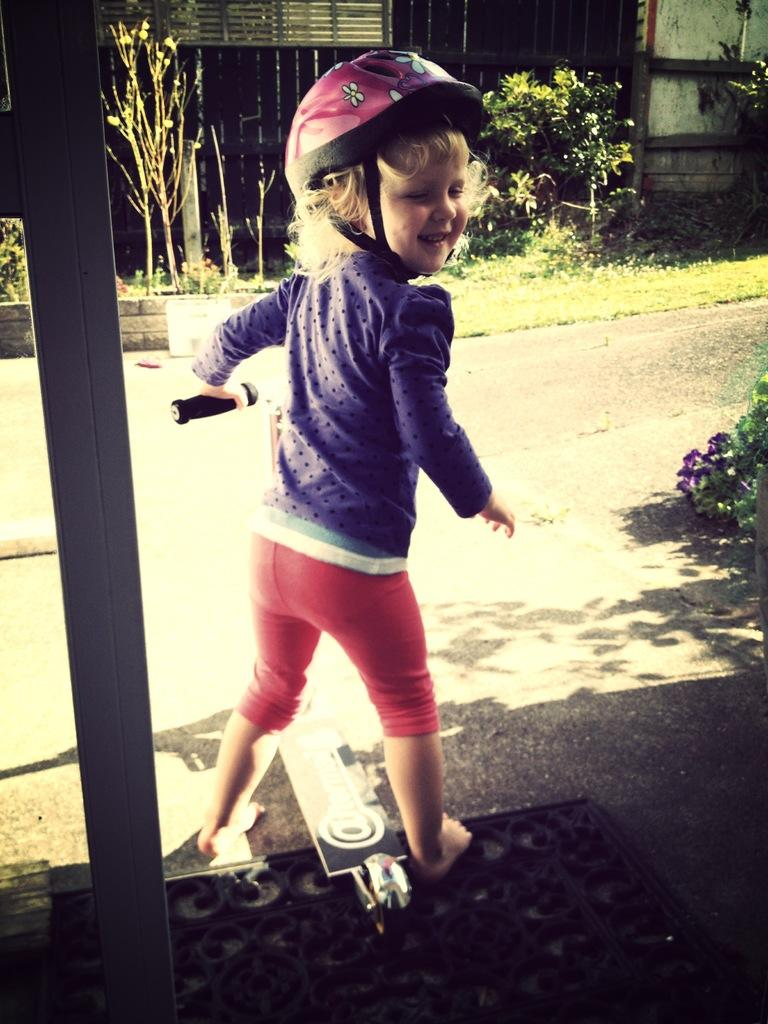What is the main subject of the image? The main subject of the image is a kid. What is the kid wearing in the image? The kid is wearing a helmet in the image. What is the kid holding in the image? The kid is holding a skate scooter in the image. What can be seen in the background of the image? There is a pole, plants, and a house in the background of the image. What type of ornament is hanging from the kid's eye in the image? There is no ornament hanging from the kid's eye in the image, nor is there any reference to an eye in the provided facts. 